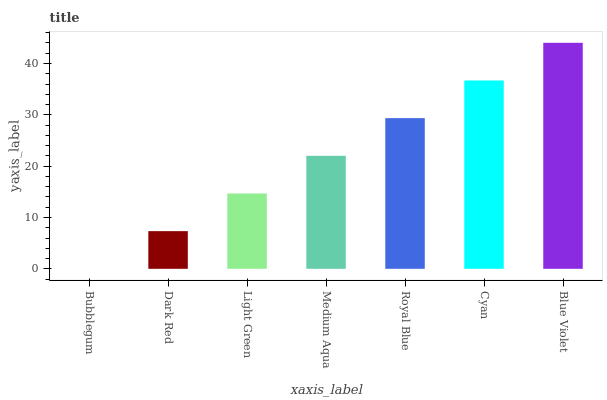Is Bubblegum the minimum?
Answer yes or no. Yes. Is Blue Violet the maximum?
Answer yes or no. Yes. Is Dark Red the minimum?
Answer yes or no. No. Is Dark Red the maximum?
Answer yes or no. No. Is Dark Red greater than Bubblegum?
Answer yes or no. Yes. Is Bubblegum less than Dark Red?
Answer yes or no. Yes. Is Bubblegum greater than Dark Red?
Answer yes or no. No. Is Dark Red less than Bubblegum?
Answer yes or no. No. Is Medium Aqua the high median?
Answer yes or no. Yes. Is Medium Aqua the low median?
Answer yes or no. Yes. Is Cyan the high median?
Answer yes or no. No. Is Dark Red the low median?
Answer yes or no. No. 